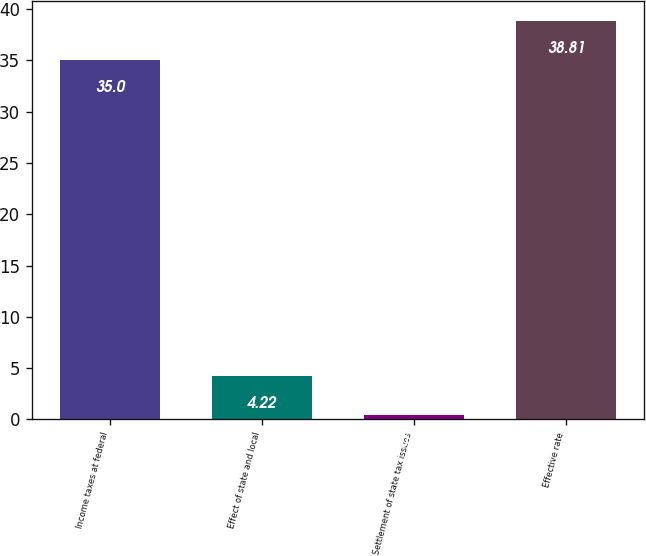Convert chart to OTSL. <chart><loc_0><loc_0><loc_500><loc_500><bar_chart><fcel>Income taxes at federal<fcel>Effect of state and local<fcel>Settlement of state tax issues<fcel>Effective rate<nl><fcel>35<fcel>4.22<fcel>0.41<fcel>38.81<nl></chart> 